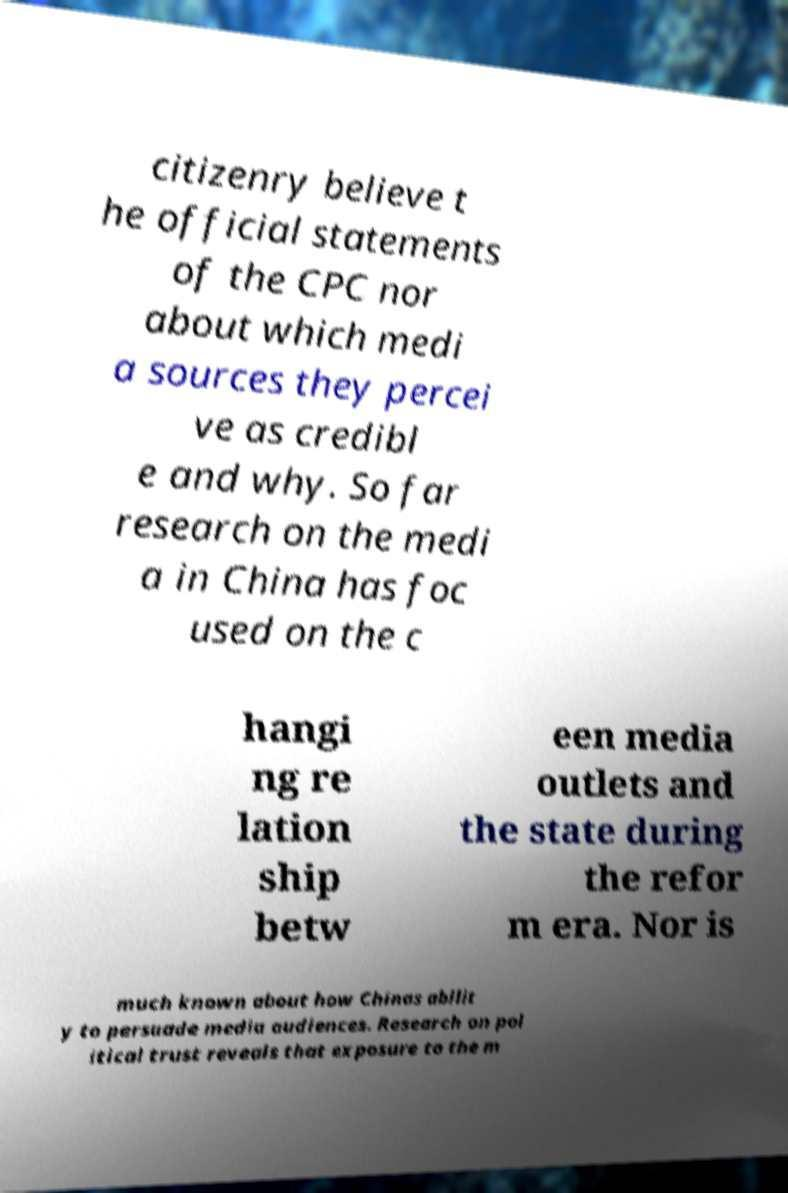For documentation purposes, I need the text within this image transcribed. Could you provide that? citizenry believe t he official statements of the CPC nor about which medi a sources they percei ve as credibl e and why. So far research on the medi a in China has foc used on the c hangi ng re lation ship betw een media outlets and the state during the refor m era. Nor is much known about how Chinas abilit y to persuade media audiences. Research on pol itical trust reveals that exposure to the m 